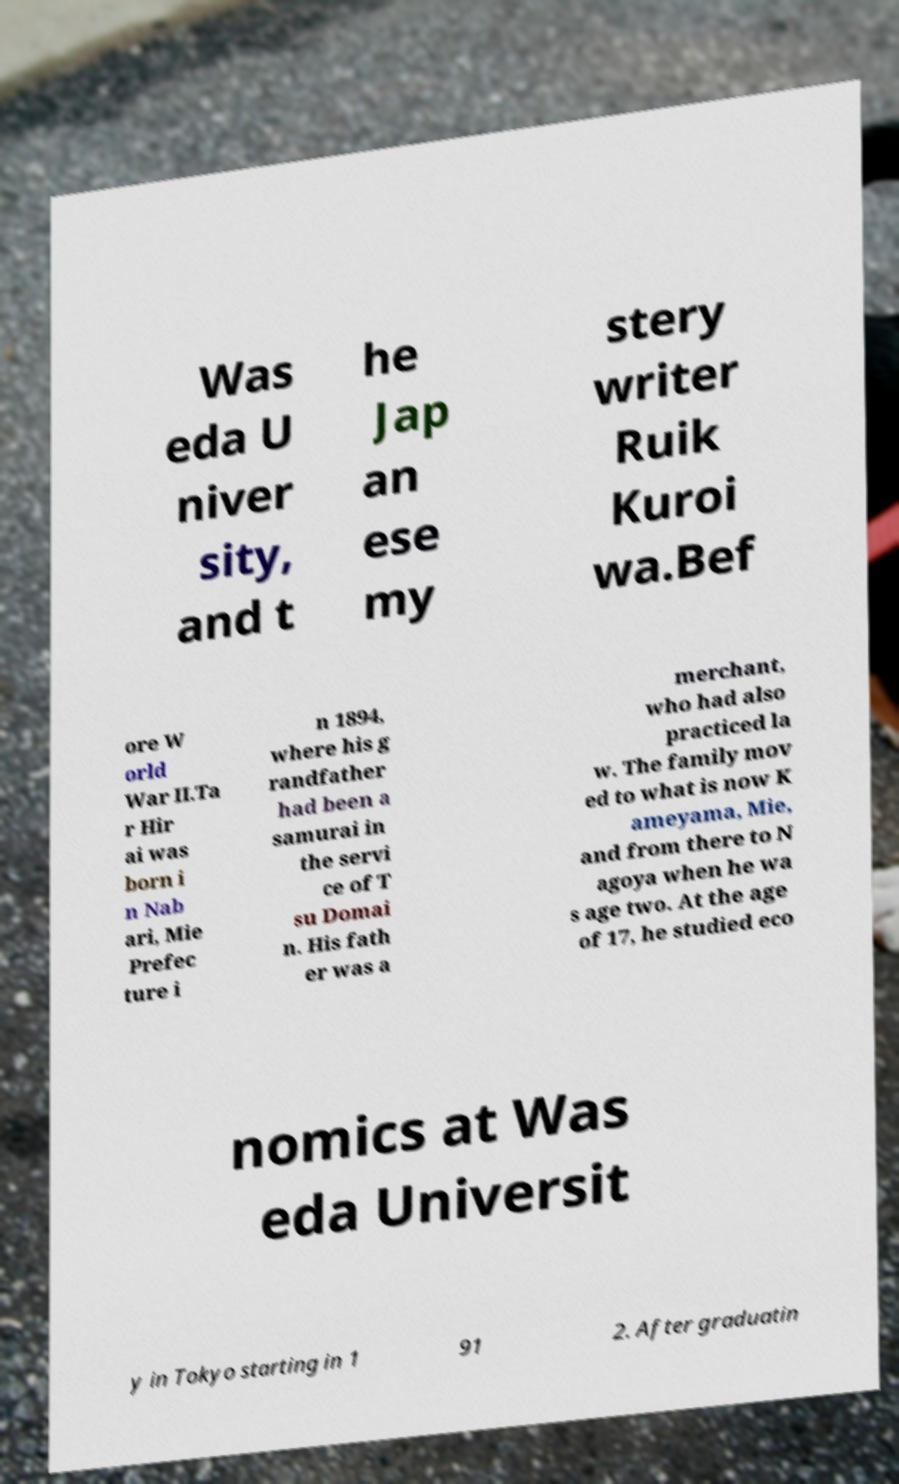Could you assist in decoding the text presented in this image and type it out clearly? Was eda U niver sity, and t he Jap an ese my stery writer Ruik Kuroi wa.Bef ore W orld War II.Ta r Hir ai was born i n Nab ari, Mie Prefec ture i n 1894, where his g randfather had been a samurai in the servi ce of T su Domai n. His fath er was a merchant, who had also practiced la w. The family mov ed to what is now K ameyama, Mie, and from there to N agoya when he wa s age two. At the age of 17, he studied eco nomics at Was eda Universit y in Tokyo starting in 1 91 2. After graduatin 